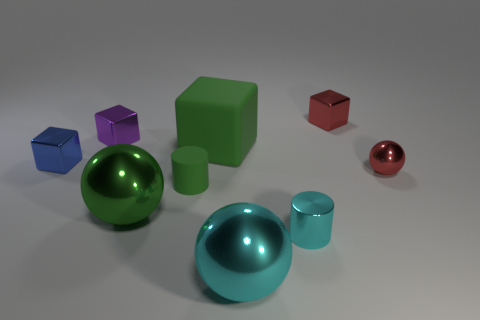There is a shiny thing that is the same color as the tiny ball; what size is it?
Your answer should be compact. Small. Are there any green metallic balls of the same size as the cyan ball?
Your response must be concise. Yes. Do the block in front of the big matte object and the green cube have the same material?
Provide a short and direct response. No. Are there an equal number of green metal balls that are left of the big cube and tiny metal cubes left of the small cyan metallic thing?
Offer a terse response. No. The metallic thing that is in front of the tiny red metal sphere and on the left side of the matte cube has what shape?
Offer a terse response. Sphere. What number of tiny purple blocks are to the left of the purple cube?
Make the answer very short. 0. How many other things are there of the same shape as the tiny purple thing?
Provide a succinct answer. 3. Is the number of small green matte objects less than the number of tiny cubes?
Give a very brief answer. Yes. What is the size of the metallic sphere that is both to the right of the small rubber cylinder and in front of the tiny ball?
Offer a very short reply. Large. There is a purple metal object to the left of the small cube that is on the right side of the large sphere on the left side of the large green matte block; how big is it?
Provide a succinct answer. Small. 